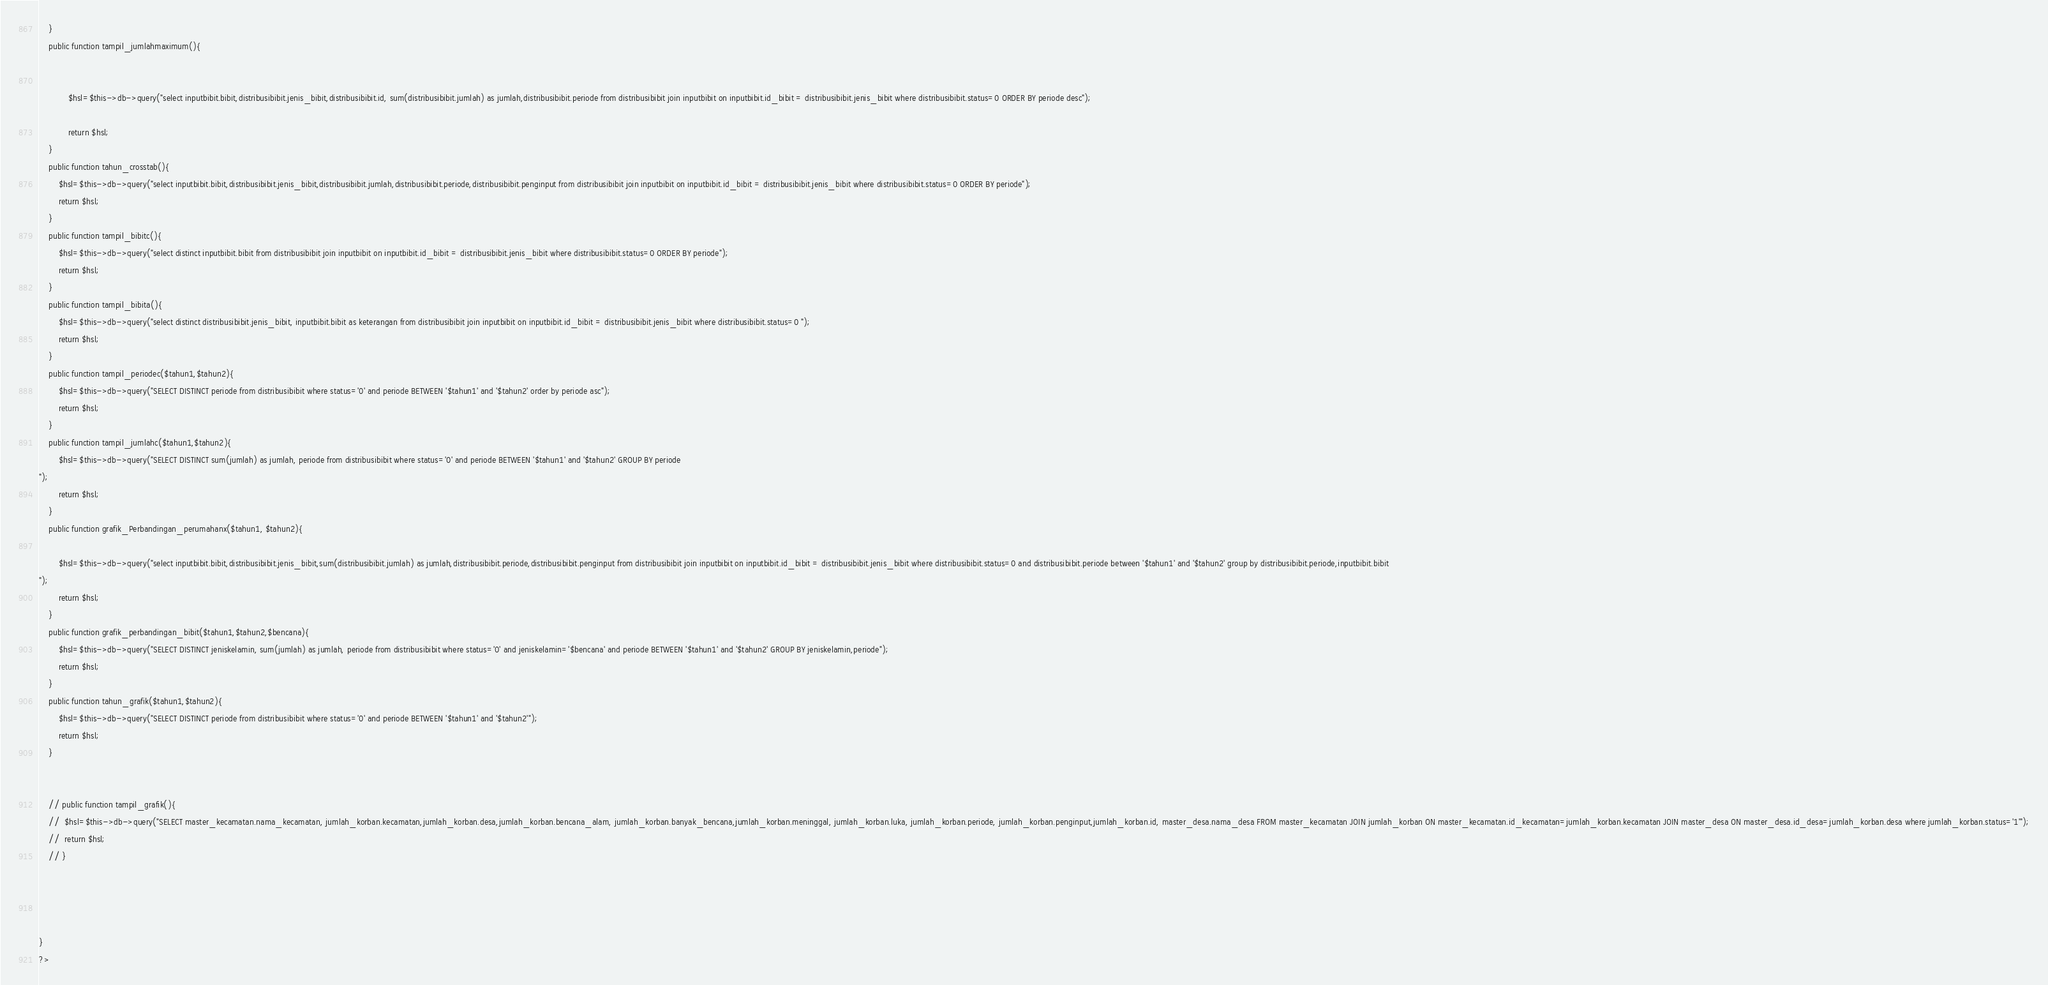Convert code to text. <code><loc_0><loc_0><loc_500><loc_500><_PHP_>	}
	public function tampil_jumlahmaximum(){
			
			
			$hsl=$this->db->query("select inputbibit.bibit,distribusibibit.jenis_bibit,distribusibibit.id, sum(distribusibibit.jumlah) as jumlah,distribusibibit.periode from distribusibibit join inputbibit on inputbibit.id_bibit = distribusibibit.jenis_bibit where distribusibibit.status=0 ORDER BY periode desc");

			return $hsl;
	}
	public function tahun_crosstab(){
		$hsl=$this->db->query("select inputbibit.bibit,distribusibibit.jenis_bibit,distribusibibit.jumlah,distribusibibit.periode,distribusibibit.penginput from distribusibibit join inputbibit on inputbibit.id_bibit = distribusibibit.jenis_bibit where distribusibibit.status=0 ORDER BY periode");
		return $hsl;
	}
	public function tampil_bibitc(){
		$hsl=$this->db->query("select distinct inputbibit.bibit from distribusibibit join inputbibit on inputbibit.id_bibit = distribusibibit.jenis_bibit where distribusibibit.status=0 ORDER BY periode");
		return $hsl;
	}
	public function tampil_bibita(){
		$hsl=$this->db->query("select distinct distribusibibit.jenis_bibit, inputbibit.bibit as keterangan from distribusibibit join inputbibit on inputbibit.id_bibit = distribusibibit.jenis_bibit where distribusibibit.status=0 ");
		return $hsl;
	}
	public function tampil_periodec($tahun1,$tahun2){
		$hsl=$this->db->query("SELECT DISTINCT periode from distribusibibit where status='0' and periode BETWEEN '$tahun1' and '$tahun2' order by periode asc");
		return $hsl;
	}
	public function tampil_jumlahc($tahun1,$tahun2){
		$hsl=$this->db->query("SELECT DISTINCT sum(jumlah) as jumlah, periode from distribusibibit where status='0' and periode BETWEEN '$tahun1' and '$tahun2' GROUP BY periode
");
		return $hsl;
	}
	public function grafik_Perbandingan_perumahanx($tahun1, $tahun2){

		$hsl=$this->db->query("select inputbibit.bibit,distribusibibit.jenis_bibit,sum(distribusibibit.jumlah) as jumlah,distribusibibit.periode,distribusibibit.penginput from distribusibibit join inputbibit on inputbibit.id_bibit = distribusibibit.jenis_bibit where distribusibibit.status=0 and distribusibibit.periode between '$tahun1' and '$tahun2' group by distribusibibit.periode,inputbibit.bibit
");
		return $hsl;
	}
	public function grafik_perbandingan_bibit($tahun1,$tahun2,$bencana){
		$hsl=$this->db->query("SELECT DISTINCT jeniskelamin, sum(jumlah) as jumlah, periode from distribusibibit where status='0' and jeniskelamin='$bencana' and periode BETWEEN '$tahun1' and '$tahun2' GROUP BY jeniskelamin,periode");
		return $hsl;
	}
	public function tahun_grafik($tahun1,$tahun2){
		$hsl=$this->db->query("SELECT DISTINCT periode from distribusibibit where status='0' and periode BETWEEN '$tahun1' and '$tahun2'");
		return $hsl;
	}
	

	// public function tampil_grafik(){
	// 	$hsl=$this->db->query("SELECT master_kecamatan.nama_kecamatan, jumlah_korban.kecamatan,jumlah_korban.desa,jumlah_korban.bencana_alam, jumlah_korban.banyak_bencana,jumlah_korban.meninggal, jumlah_korban.luka, jumlah_korban.periode, jumlah_korban.penginput,jumlah_korban.id, master_desa.nama_desa FROM master_kecamatan JOIN jumlah_korban ON master_kecamatan.id_kecamatan=jumlah_korban.kecamatan JOIN master_desa ON master_desa.id_desa=jumlah_korban.desa where jumlah_korban.status='1'");
	// 	return $hsl;
	// }
	



}
?>


</code> 